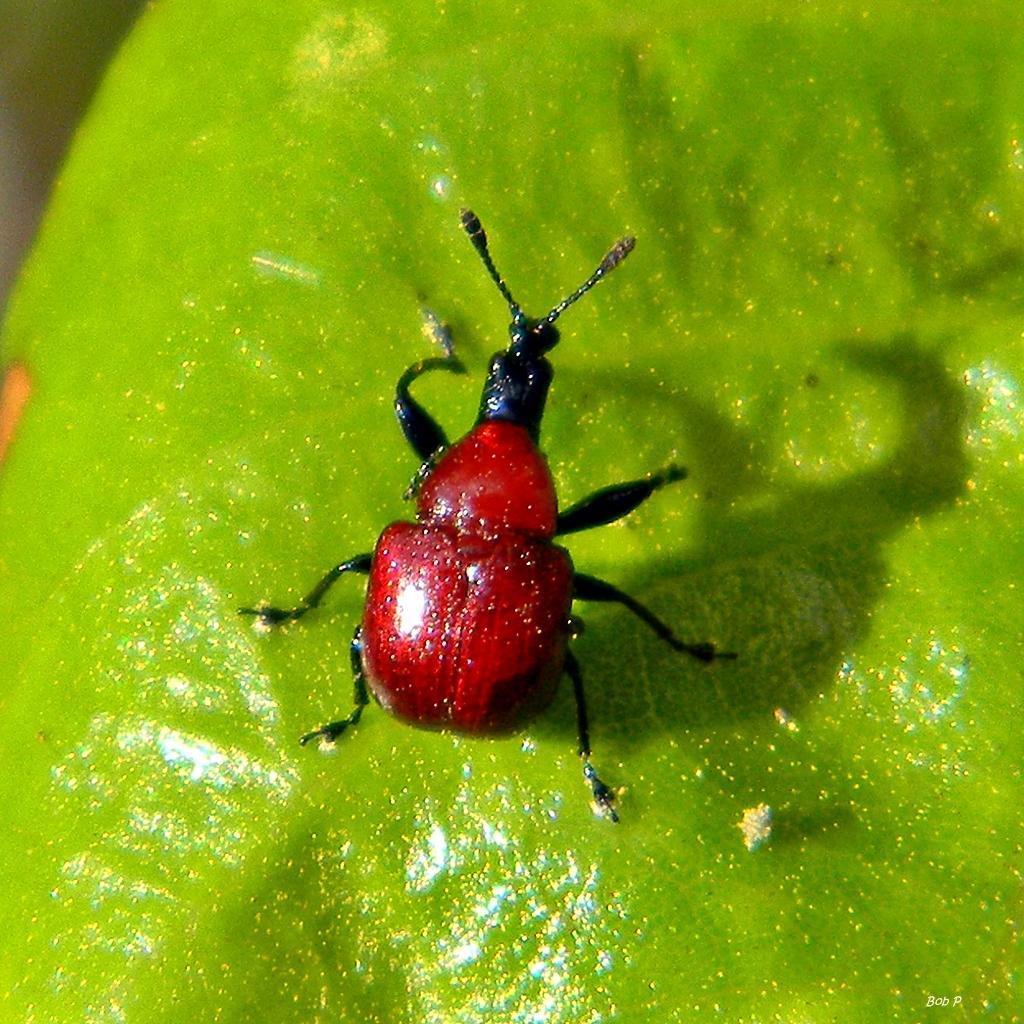Please provide a concise description of this image. In the center of the image, we can see an insect on the leaf. 